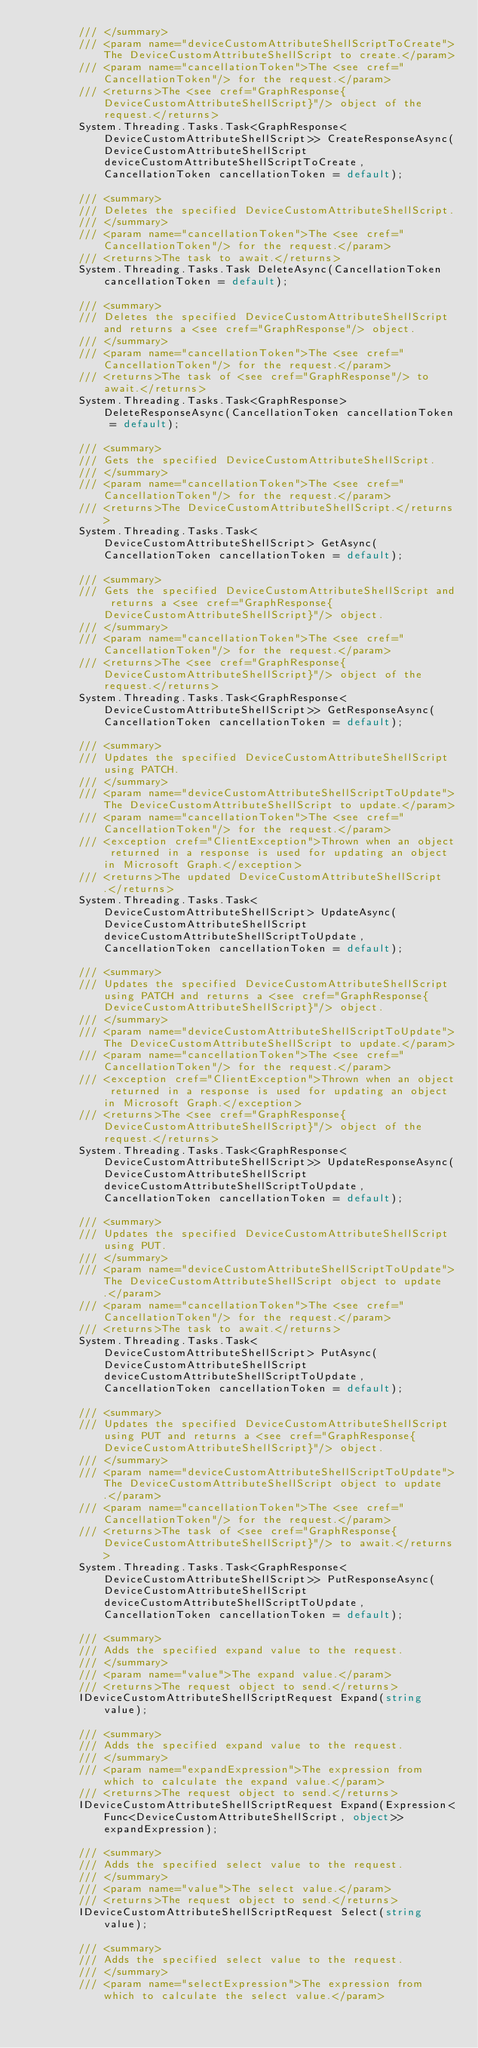<code> <loc_0><loc_0><loc_500><loc_500><_C#_>        /// </summary>
        /// <param name="deviceCustomAttributeShellScriptToCreate">The DeviceCustomAttributeShellScript to create.</param>
        /// <param name="cancellationToken">The <see cref="CancellationToken"/> for the request.</param>
        /// <returns>The <see cref="GraphResponse{DeviceCustomAttributeShellScript}"/> object of the request.</returns>
        System.Threading.Tasks.Task<GraphResponse<DeviceCustomAttributeShellScript>> CreateResponseAsync(DeviceCustomAttributeShellScript deviceCustomAttributeShellScriptToCreate, CancellationToken cancellationToken = default);

        /// <summary>
        /// Deletes the specified DeviceCustomAttributeShellScript.
        /// </summary>
        /// <param name="cancellationToken">The <see cref="CancellationToken"/> for the request.</param>
        /// <returns>The task to await.</returns>
        System.Threading.Tasks.Task DeleteAsync(CancellationToken cancellationToken = default);

        /// <summary>
        /// Deletes the specified DeviceCustomAttributeShellScript and returns a <see cref="GraphResponse"/> object.
        /// </summary>
        /// <param name="cancellationToken">The <see cref="CancellationToken"/> for the request.</param>
        /// <returns>The task of <see cref="GraphResponse"/> to await.</returns>
        System.Threading.Tasks.Task<GraphResponse> DeleteResponseAsync(CancellationToken cancellationToken = default);

        /// <summary>
        /// Gets the specified DeviceCustomAttributeShellScript.
        /// </summary>
        /// <param name="cancellationToken">The <see cref="CancellationToken"/> for the request.</param>
        /// <returns>The DeviceCustomAttributeShellScript.</returns>
        System.Threading.Tasks.Task<DeviceCustomAttributeShellScript> GetAsync(CancellationToken cancellationToken = default);

        /// <summary>
        /// Gets the specified DeviceCustomAttributeShellScript and returns a <see cref="GraphResponse{DeviceCustomAttributeShellScript}"/> object.
        /// </summary>
        /// <param name="cancellationToken">The <see cref="CancellationToken"/> for the request.</param>
        /// <returns>The <see cref="GraphResponse{DeviceCustomAttributeShellScript}"/> object of the request.</returns>
        System.Threading.Tasks.Task<GraphResponse<DeviceCustomAttributeShellScript>> GetResponseAsync(CancellationToken cancellationToken = default);

        /// <summary>
        /// Updates the specified DeviceCustomAttributeShellScript using PATCH.
        /// </summary>
        /// <param name="deviceCustomAttributeShellScriptToUpdate">The DeviceCustomAttributeShellScript to update.</param>
        /// <param name="cancellationToken">The <see cref="CancellationToken"/> for the request.</param>
        /// <exception cref="ClientException">Thrown when an object returned in a response is used for updating an object in Microsoft Graph.</exception>
        /// <returns>The updated DeviceCustomAttributeShellScript.</returns>
        System.Threading.Tasks.Task<DeviceCustomAttributeShellScript> UpdateAsync(DeviceCustomAttributeShellScript deviceCustomAttributeShellScriptToUpdate, CancellationToken cancellationToken = default);

        /// <summary>
        /// Updates the specified DeviceCustomAttributeShellScript using PATCH and returns a <see cref="GraphResponse{DeviceCustomAttributeShellScript}"/> object.
        /// </summary>
        /// <param name="deviceCustomAttributeShellScriptToUpdate">The DeviceCustomAttributeShellScript to update.</param>
        /// <param name="cancellationToken">The <see cref="CancellationToken"/> for the request.</param>
        /// <exception cref="ClientException">Thrown when an object returned in a response is used for updating an object in Microsoft Graph.</exception>
        /// <returns>The <see cref="GraphResponse{DeviceCustomAttributeShellScript}"/> object of the request.</returns>
        System.Threading.Tasks.Task<GraphResponse<DeviceCustomAttributeShellScript>> UpdateResponseAsync(DeviceCustomAttributeShellScript deviceCustomAttributeShellScriptToUpdate, CancellationToken cancellationToken = default);

        /// <summary>
        /// Updates the specified DeviceCustomAttributeShellScript using PUT.
        /// </summary>
        /// <param name="deviceCustomAttributeShellScriptToUpdate">The DeviceCustomAttributeShellScript object to update.</param>
        /// <param name="cancellationToken">The <see cref="CancellationToken"/> for the request.</param>
        /// <returns>The task to await.</returns>
        System.Threading.Tasks.Task<DeviceCustomAttributeShellScript> PutAsync(DeviceCustomAttributeShellScript deviceCustomAttributeShellScriptToUpdate, CancellationToken cancellationToken = default);

        /// <summary>
        /// Updates the specified DeviceCustomAttributeShellScript using PUT and returns a <see cref="GraphResponse{DeviceCustomAttributeShellScript}"/> object.
        /// </summary>
        /// <param name="deviceCustomAttributeShellScriptToUpdate">The DeviceCustomAttributeShellScript object to update.</param>
        /// <param name="cancellationToken">The <see cref="CancellationToken"/> for the request.</param>
        /// <returns>The task of <see cref="GraphResponse{DeviceCustomAttributeShellScript}"/> to await.</returns>
        System.Threading.Tasks.Task<GraphResponse<DeviceCustomAttributeShellScript>> PutResponseAsync(DeviceCustomAttributeShellScript deviceCustomAttributeShellScriptToUpdate, CancellationToken cancellationToken = default);

        /// <summary>
        /// Adds the specified expand value to the request.
        /// </summary>
        /// <param name="value">The expand value.</param>
        /// <returns>The request object to send.</returns>
        IDeviceCustomAttributeShellScriptRequest Expand(string value);

        /// <summary>
        /// Adds the specified expand value to the request.
        /// </summary>
        /// <param name="expandExpression">The expression from which to calculate the expand value.</param>
        /// <returns>The request object to send.</returns>
        IDeviceCustomAttributeShellScriptRequest Expand(Expression<Func<DeviceCustomAttributeShellScript, object>> expandExpression);

        /// <summary>
        /// Adds the specified select value to the request.
        /// </summary>
        /// <param name="value">The select value.</param>
        /// <returns>The request object to send.</returns>
        IDeviceCustomAttributeShellScriptRequest Select(string value);

        /// <summary>
        /// Adds the specified select value to the request.
        /// </summary>
        /// <param name="selectExpression">The expression from which to calculate the select value.</param></code> 